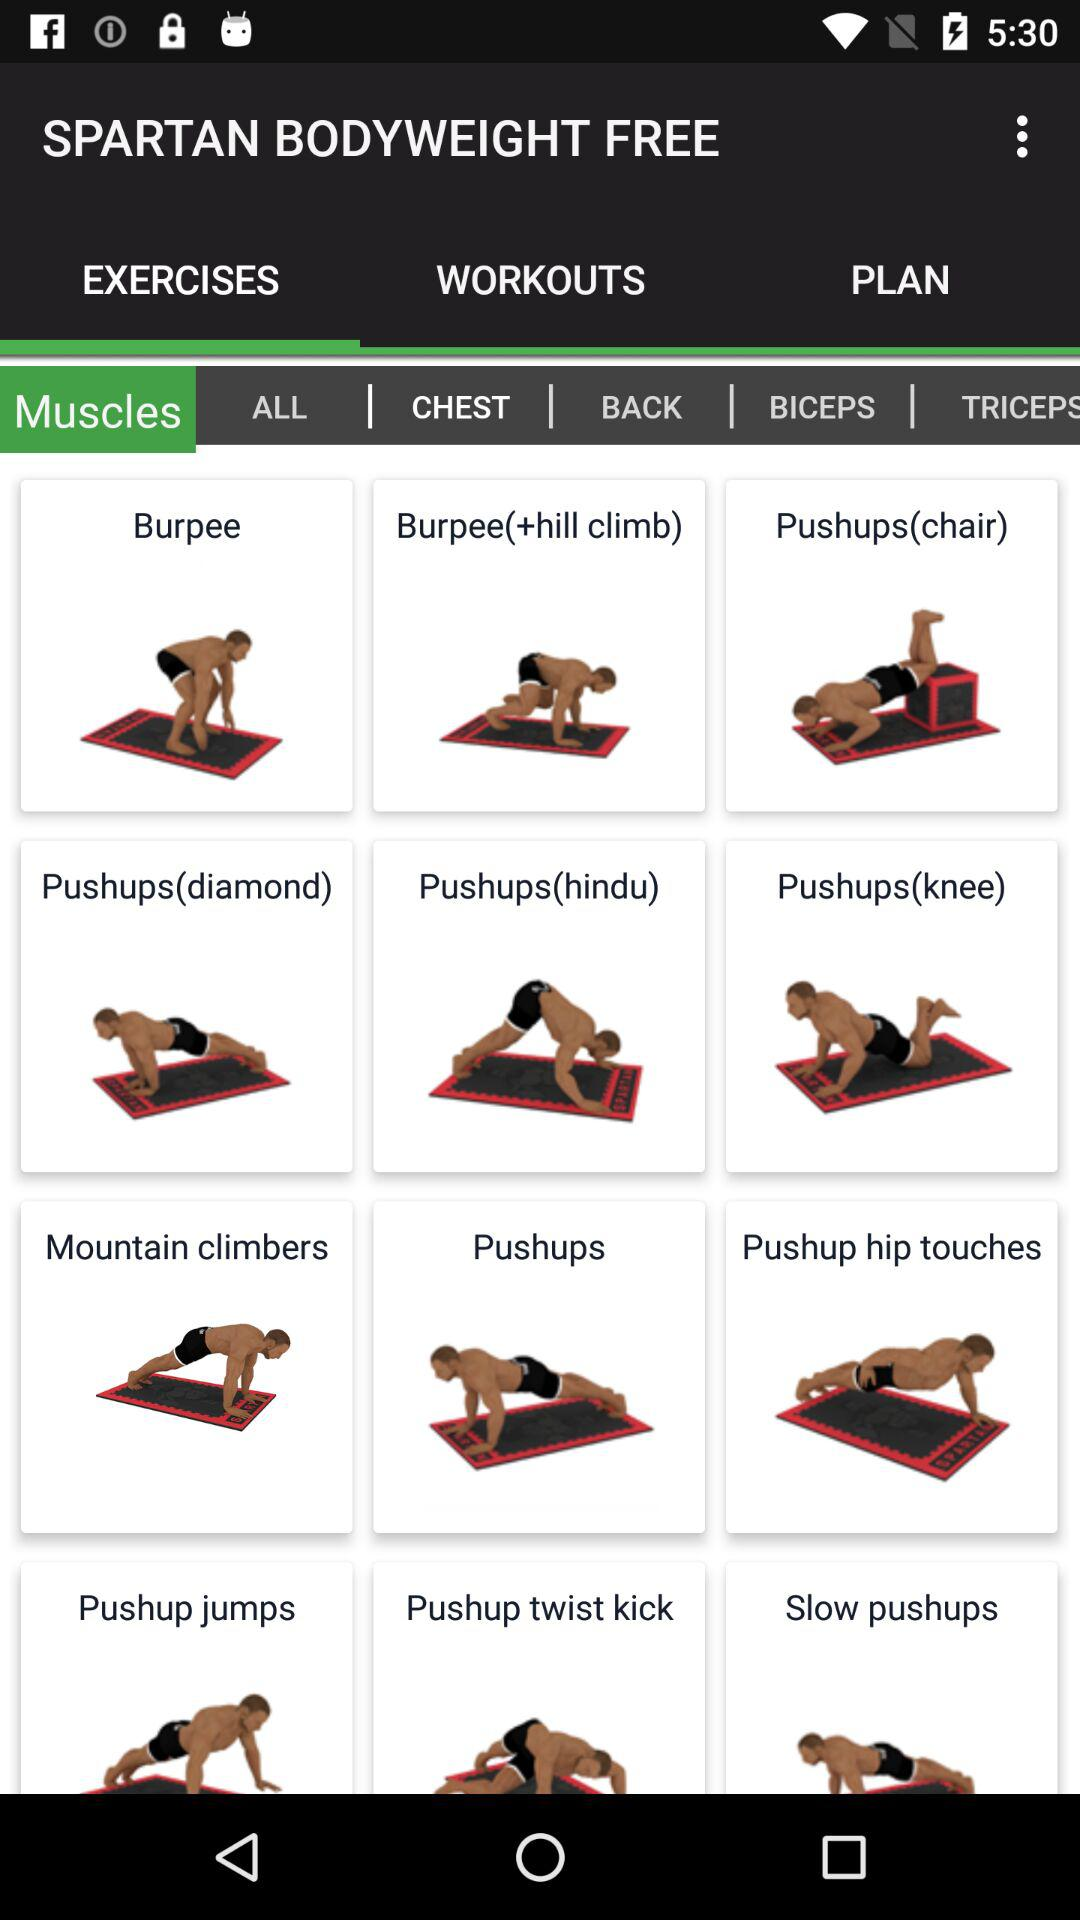What are the names of muscle exercises? The names of muscle exercises are "CHEST", "BACK", "BICEPS" and "TRICEPS". 